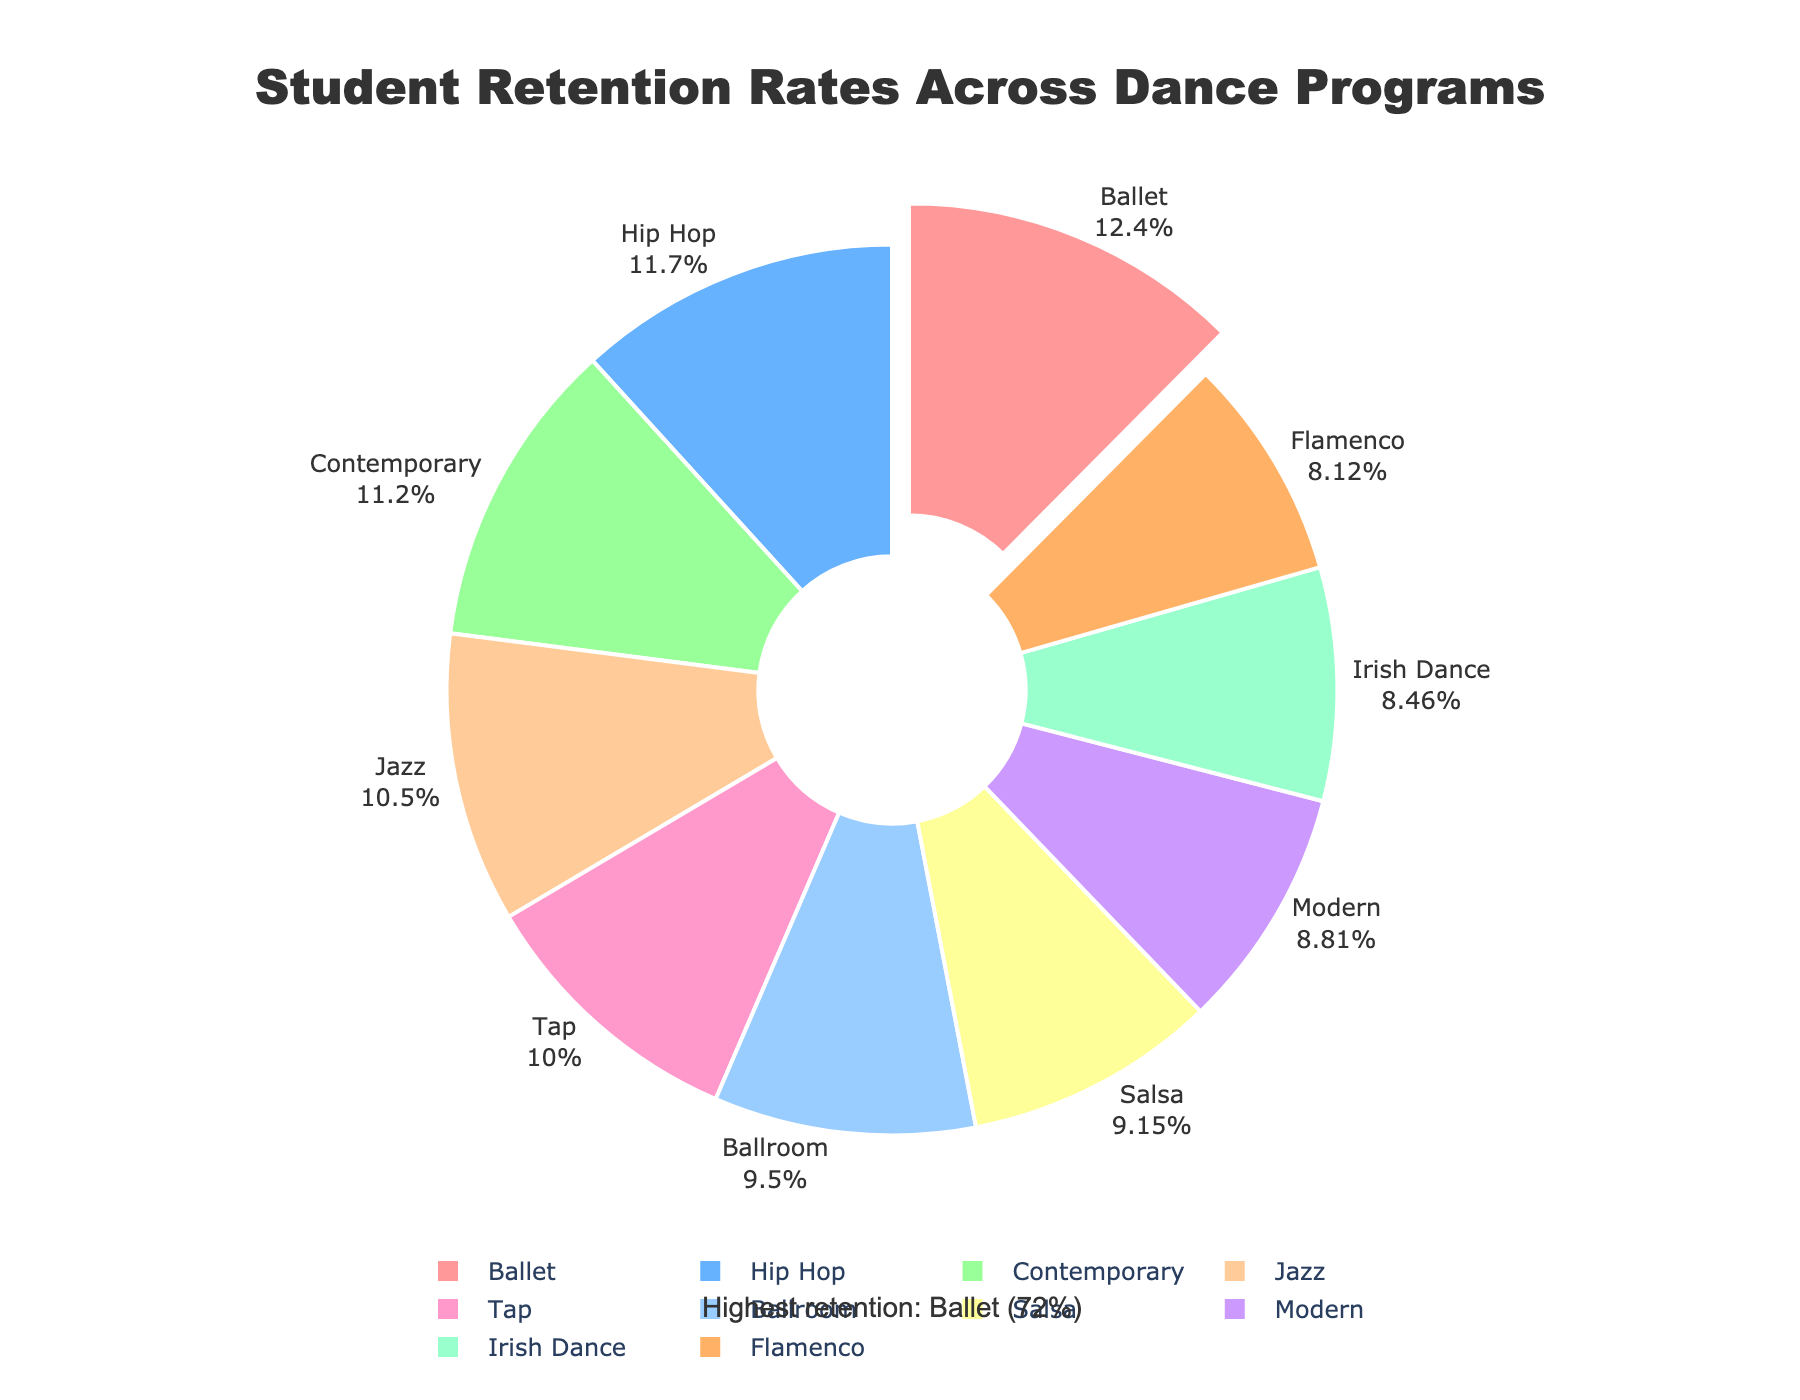What is the retention rate for Ballet? By observing the figure, we can directly see that the retention rate for the Ballet program is indicated at 72%
Answer: 72% Which dance program has the lowest retention rate? The figure shows that the Flamenco program has the lowest retention rate among all shown programs
Answer: Flamenco What is the difference in retention rates between Ballet and Tap programs? The retention rate for Ballet is 72% and for Tap, it is 58%. The difference is calculated as 72% - 58% = 14%
Answer: 14% Which programs have retention rates greater than 60%? From the figure, we can see that Ballet, Hip Hop, Contemporary, and Jazz have retention rates greater than 60%
Answer: Ballet, Hip Hop, Contemporary, Jazz How do the retention rates of Contemporary and Irish Dance compare? The retention rate for Contemporary is 65%, whereas for Irish Dance it is 49%. Contemporary has a higher retention rate by 16%
Answer: Contemporary is higher by 16% What percentage of the total retention do the top three programs (Ballet, Hip Hop, and Contemporary) represent? The percentages shown for Ballet, Hip Hop, and Contemporary are 72%, 68%, and 65%. These sum to 72 + 68 + 65 = 205. Then, dividing by the total (sum of all rates), which is 579, and multiplying by 100, we get approximately (205/579) * 100 ≈ 35.4%
Answer: 35.4% Which color represents the Ballet program in the pie chart? Ballet is highlighted to stand out at the beginning of the pie chart and is shown in red
Answer: Red How do the retention rates for Ballroom and Salsa compare? Ballroom has a retention rate of 55%, and Salsa has a rate of 53%. Ballroom has a slightly higher rate by 2%
Answer: Ballroom is higher by 2% What retention rate does the annotation in the figure emphasize and for which program? The annotation in the figure emphasizes a retention rate of 72% for the Ballet program
Answer: 72% for Ballet What is the median retention rate among all listed programs? Sorting the retention rates in ascending order: 47, 49, 51, 53, 55, 58, 61, 65, 68, 72, the middle value (median) is 55%
Answer: 55% 